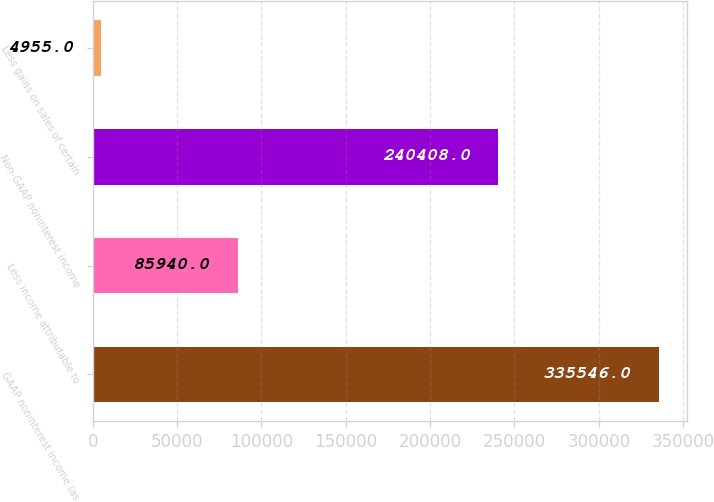<chart> <loc_0><loc_0><loc_500><loc_500><bar_chart><fcel>GAAP noninterest income (as<fcel>Less income attributable to<fcel>Non-GAAP noninterest income<fcel>Less gains on sales of certain<nl><fcel>335546<fcel>85940<fcel>240408<fcel>4955<nl></chart> 